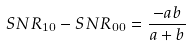<formula> <loc_0><loc_0><loc_500><loc_500>S N R _ { 1 0 } - S N R _ { 0 0 } = \frac { - a b } { a + b }</formula> 